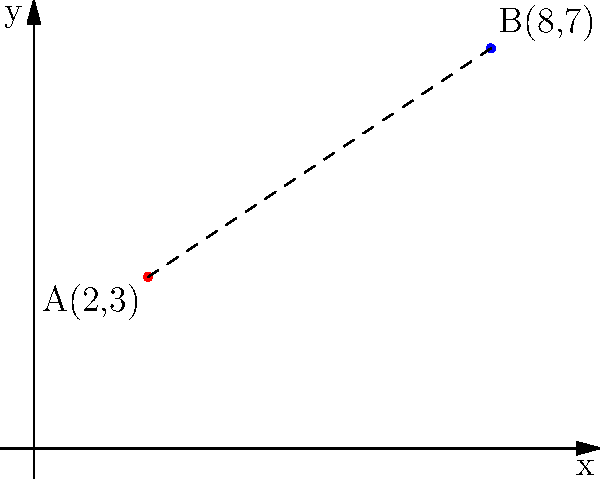Two aircraft are detected on a coordinate plane representing a section of airspace. Aircraft A is at position (2,3) and Aircraft B is at position (8,7). Calculate the straight-line distance between these two aircraft positions to the nearest tenth of a unit. To find the distance between two points on a coordinate plane, we use the distance formula:

$$d = \sqrt{(x_2-x_1)^2 + (y_2-y_1)^2}$$

Where $(x_1,y_1)$ is the position of Aircraft A and $(x_2,y_2)$ is the position of Aircraft B.

Step 1: Identify the coordinates
Aircraft A: $(x_1,y_1) = (2,3)$
Aircraft B: $(x_2,y_2) = (8,7)$

Step 2: Plug the values into the distance formula
$$d = \sqrt{(8-2)^2 + (7-3)^2}$$

Step 3: Simplify the expressions inside the parentheses
$$d = \sqrt{6^2 + 4^2}$$

Step 4: Calculate the squares
$$d = \sqrt{36 + 16}$$

Step 5: Add the values under the square root
$$d = \sqrt{52}$$

Step 6: Calculate the square root and round to the nearest tenth
$$d \approx 7.2$$

Therefore, the distance between the two aircraft positions is approximately 7.2 units.
Answer: 7.2 units 